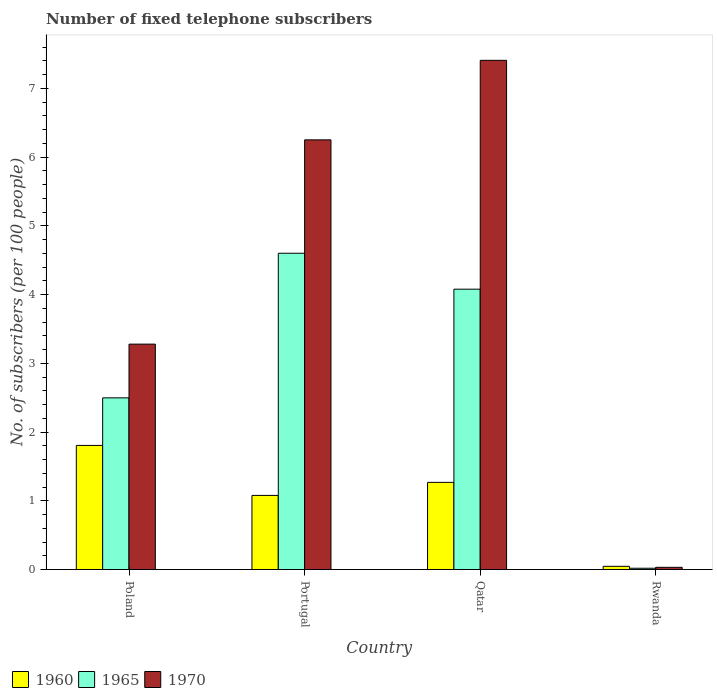How many groups of bars are there?
Give a very brief answer. 4. Are the number of bars per tick equal to the number of legend labels?
Make the answer very short. Yes. What is the label of the 2nd group of bars from the left?
Offer a terse response. Portugal. In how many cases, is the number of bars for a given country not equal to the number of legend labels?
Your answer should be compact. 0. What is the number of fixed telephone subscribers in 1960 in Poland?
Give a very brief answer. 1.81. Across all countries, what is the maximum number of fixed telephone subscribers in 1965?
Give a very brief answer. 4.6. Across all countries, what is the minimum number of fixed telephone subscribers in 1965?
Your response must be concise. 0.02. In which country was the number of fixed telephone subscribers in 1960 minimum?
Your answer should be very brief. Rwanda. What is the total number of fixed telephone subscribers in 1965 in the graph?
Your answer should be compact. 11.2. What is the difference between the number of fixed telephone subscribers in 1970 in Poland and that in Qatar?
Make the answer very short. -4.13. What is the difference between the number of fixed telephone subscribers in 1970 in Qatar and the number of fixed telephone subscribers in 1960 in Rwanda?
Offer a very short reply. 7.36. What is the average number of fixed telephone subscribers in 1960 per country?
Your answer should be compact. 1.05. What is the difference between the number of fixed telephone subscribers of/in 1970 and number of fixed telephone subscribers of/in 1965 in Poland?
Your response must be concise. 0.78. In how many countries, is the number of fixed telephone subscribers in 1960 greater than 5.4?
Offer a very short reply. 0. What is the ratio of the number of fixed telephone subscribers in 1960 in Portugal to that in Rwanda?
Make the answer very short. 23.15. What is the difference between the highest and the second highest number of fixed telephone subscribers in 1960?
Offer a terse response. 0.54. What is the difference between the highest and the lowest number of fixed telephone subscribers in 1960?
Make the answer very short. 1.76. In how many countries, is the number of fixed telephone subscribers in 1970 greater than the average number of fixed telephone subscribers in 1970 taken over all countries?
Provide a short and direct response. 2. What does the 3rd bar from the left in Qatar represents?
Provide a succinct answer. 1970. What does the 1st bar from the right in Qatar represents?
Your answer should be compact. 1970. Is it the case that in every country, the sum of the number of fixed telephone subscribers in 1960 and number of fixed telephone subscribers in 1965 is greater than the number of fixed telephone subscribers in 1970?
Your response must be concise. No. How many bars are there?
Your response must be concise. 12. What is the difference between two consecutive major ticks on the Y-axis?
Provide a short and direct response. 1. Are the values on the major ticks of Y-axis written in scientific E-notation?
Give a very brief answer. No. How many legend labels are there?
Your answer should be very brief. 3. How are the legend labels stacked?
Keep it short and to the point. Horizontal. What is the title of the graph?
Your answer should be compact. Number of fixed telephone subscribers. What is the label or title of the Y-axis?
Your response must be concise. No. of subscribers (per 100 people). What is the No. of subscribers (per 100 people) in 1960 in Poland?
Your response must be concise. 1.81. What is the No. of subscribers (per 100 people) of 1965 in Poland?
Your answer should be very brief. 2.5. What is the No. of subscribers (per 100 people) of 1970 in Poland?
Keep it short and to the point. 3.28. What is the No. of subscribers (per 100 people) in 1960 in Portugal?
Provide a short and direct response. 1.08. What is the No. of subscribers (per 100 people) in 1965 in Portugal?
Your answer should be compact. 4.6. What is the No. of subscribers (per 100 people) of 1970 in Portugal?
Your response must be concise. 6.25. What is the No. of subscribers (per 100 people) of 1960 in Qatar?
Give a very brief answer. 1.27. What is the No. of subscribers (per 100 people) in 1965 in Qatar?
Give a very brief answer. 4.08. What is the No. of subscribers (per 100 people) of 1970 in Qatar?
Your response must be concise. 7.41. What is the No. of subscribers (per 100 people) in 1960 in Rwanda?
Your answer should be compact. 0.05. What is the No. of subscribers (per 100 people) in 1965 in Rwanda?
Ensure brevity in your answer.  0.02. What is the No. of subscribers (per 100 people) of 1970 in Rwanda?
Offer a very short reply. 0.03. Across all countries, what is the maximum No. of subscribers (per 100 people) in 1960?
Make the answer very short. 1.81. Across all countries, what is the maximum No. of subscribers (per 100 people) in 1965?
Your answer should be compact. 4.6. Across all countries, what is the maximum No. of subscribers (per 100 people) in 1970?
Ensure brevity in your answer.  7.41. Across all countries, what is the minimum No. of subscribers (per 100 people) in 1960?
Provide a succinct answer. 0.05. Across all countries, what is the minimum No. of subscribers (per 100 people) in 1965?
Your answer should be compact. 0.02. Across all countries, what is the minimum No. of subscribers (per 100 people) in 1970?
Offer a very short reply. 0.03. What is the total No. of subscribers (per 100 people) of 1960 in the graph?
Your response must be concise. 4.2. What is the total No. of subscribers (per 100 people) of 1965 in the graph?
Ensure brevity in your answer.  11.2. What is the total No. of subscribers (per 100 people) of 1970 in the graph?
Provide a short and direct response. 16.97. What is the difference between the No. of subscribers (per 100 people) in 1960 in Poland and that in Portugal?
Your response must be concise. 0.73. What is the difference between the No. of subscribers (per 100 people) of 1965 in Poland and that in Portugal?
Offer a very short reply. -2.1. What is the difference between the No. of subscribers (per 100 people) of 1970 in Poland and that in Portugal?
Your answer should be compact. -2.97. What is the difference between the No. of subscribers (per 100 people) of 1960 in Poland and that in Qatar?
Your response must be concise. 0.54. What is the difference between the No. of subscribers (per 100 people) in 1965 in Poland and that in Qatar?
Make the answer very short. -1.58. What is the difference between the No. of subscribers (per 100 people) of 1970 in Poland and that in Qatar?
Offer a very short reply. -4.13. What is the difference between the No. of subscribers (per 100 people) of 1960 in Poland and that in Rwanda?
Offer a terse response. 1.76. What is the difference between the No. of subscribers (per 100 people) of 1965 in Poland and that in Rwanda?
Make the answer very short. 2.48. What is the difference between the No. of subscribers (per 100 people) in 1970 in Poland and that in Rwanda?
Make the answer very short. 3.25. What is the difference between the No. of subscribers (per 100 people) in 1960 in Portugal and that in Qatar?
Your response must be concise. -0.19. What is the difference between the No. of subscribers (per 100 people) in 1965 in Portugal and that in Qatar?
Make the answer very short. 0.52. What is the difference between the No. of subscribers (per 100 people) in 1970 in Portugal and that in Qatar?
Give a very brief answer. -1.16. What is the difference between the No. of subscribers (per 100 people) in 1960 in Portugal and that in Rwanda?
Offer a very short reply. 1.03. What is the difference between the No. of subscribers (per 100 people) in 1965 in Portugal and that in Rwanda?
Provide a succinct answer. 4.58. What is the difference between the No. of subscribers (per 100 people) in 1970 in Portugal and that in Rwanda?
Your answer should be very brief. 6.22. What is the difference between the No. of subscribers (per 100 people) of 1960 in Qatar and that in Rwanda?
Your answer should be very brief. 1.22. What is the difference between the No. of subscribers (per 100 people) of 1965 in Qatar and that in Rwanda?
Offer a terse response. 4.06. What is the difference between the No. of subscribers (per 100 people) in 1970 in Qatar and that in Rwanda?
Offer a very short reply. 7.38. What is the difference between the No. of subscribers (per 100 people) of 1960 in Poland and the No. of subscribers (per 100 people) of 1965 in Portugal?
Provide a short and direct response. -2.8. What is the difference between the No. of subscribers (per 100 people) of 1960 in Poland and the No. of subscribers (per 100 people) of 1970 in Portugal?
Provide a succinct answer. -4.45. What is the difference between the No. of subscribers (per 100 people) of 1965 in Poland and the No. of subscribers (per 100 people) of 1970 in Portugal?
Give a very brief answer. -3.75. What is the difference between the No. of subscribers (per 100 people) in 1960 in Poland and the No. of subscribers (per 100 people) in 1965 in Qatar?
Provide a short and direct response. -2.27. What is the difference between the No. of subscribers (per 100 people) in 1960 in Poland and the No. of subscribers (per 100 people) in 1970 in Qatar?
Your answer should be compact. -5.6. What is the difference between the No. of subscribers (per 100 people) in 1965 in Poland and the No. of subscribers (per 100 people) in 1970 in Qatar?
Give a very brief answer. -4.91. What is the difference between the No. of subscribers (per 100 people) in 1960 in Poland and the No. of subscribers (per 100 people) in 1965 in Rwanda?
Your response must be concise. 1.79. What is the difference between the No. of subscribers (per 100 people) in 1960 in Poland and the No. of subscribers (per 100 people) in 1970 in Rwanda?
Keep it short and to the point. 1.77. What is the difference between the No. of subscribers (per 100 people) in 1965 in Poland and the No. of subscribers (per 100 people) in 1970 in Rwanda?
Make the answer very short. 2.47. What is the difference between the No. of subscribers (per 100 people) in 1960 in Portugal and the No. of subscribers (per 100 people) in 1965 in Qatar?
Your answer should be very brief. -3. What is the difference between the No. of subscribers (per 100 people) in 1960 in Portugal and the No. of subscribers (per 100 people) in 1970 in Qatar?
Provide a short and direct response. -6.33. What is the difference between the No. of subscribers (per 100 people) of 1965 in Portugal and the No. of subscribers (per 100 people) of 1970 in Qatar?
Your answer should be compact. -2.81. What is the difference between the No. of subscribers (per 100 people) in 1960 in Portugal and the No. of subscribers (per 100 people) in 1965 in Rwanda?
Offer a very short reply. 1.06. What is the difference between the No. of subscribers (per 100 people) in 1960 in Portugal and the No. of subscribers (per 100 people) in 1970 in Rwanda?
Ensure brevity in your answer.  1.05. What is the difference between the No. of subscribers (per 100 people) in 1965 in Portugal and the No. of subscribers (per 100 people) in 1970 in Rwanda?
Keep it short and to the point. 4.57. What is the difference between the No. of subscribers (per 100 people) in 1960 in Qatar and the No. of subscribers (per 100 people) in 1965 in Rwanda?
Keep it short and to the point. 1.25. What is the difference between the No. of subscribers (per 100 people) of 1960 in Qatar and the No. of subscribers (per 100 people) of 1970 in Rwanda?
Keep it short and to the point. 1.24. What is the difference between the No. of subscribers (per 100 people) in 1965 in Qatar and the No. of subscribers (per 100 people) in 1970 in Rwanda?
Your response must be concise. 4.05. What is the average No. of subscribers (per 100 people) of 1960 per country?
Offer a terse response. 1.05. What is the average No. of subscribers (per 100 people) of 1965 per country?
Offer a very short reply. 2.8. What is the average No. of subscribers (per 100 people) of 1970 per country?
Give a very brief answer. 4.24. What is the difference between the No. of subscribers (per 100 people) in 1960 and No. of subscribers (per 100 people) in 1965 in Poland?
Provide a succinct answer. -0.69. What is the difference between the No. of subscribers (per 100 people) of 1960 and No. of subscribers (per 100 people) of 1970 in Poland?
Provide a short and direct response. -1.47. What is the difference between the No. of subscribers (per 100 people) of 1965 and No. of subscribers (per 100 people) of 1970 in Poland?
Your answer should be compact. -0.78. What is the difference between the No. of subscribers (per 100 people) of 1960 and No. of subscribers (per 100 people) of 1965 in Portugal?
Make the answer very short. -3.52. What is the difference between the No. of subscribers (per 100 people) in 1960 and No. of subscribers (per 100 people) in 1970 in Portugal?
Offer a very short reply. -5.17. What is the difference between the No. of subscribers (per 100 people) of 1965 and No. of subscribers (per 100 people) of 1970 in Portugal?
Your answer should be very brief. -1.65. What is the difference between the No. of subscribers (per 100 people) of 1960 and No. of subscribers (per 100 people) of 1965 in Qatar?
Your response must be concise. -2.81. What is the difference between the No. of subscribers (per 100 people) of 1960 and No. of subscribers (per 100 people) of 1970 in Qatar?
Make the answer very short. -6.14. What is the difference between the No. of subscribers (per 100 people) of 1965 and No. of subscribers (per 100 people) of 1970 in Qatar?
Keep it short and to the point. -3.33. What is the difference between the No. of subscribers (per 100 people) in 1960 and No. of subscribers (per 100 people) in 1965 in Rwanda?
Make the answer very short. 0.03. What is the difference between the No. of subscribers (per 100 people) of 1960 and No. of subscribers (per 100 people) of 1970 in Rwanda?
Make the answer very short. 0.01. What is the difference between the No. of subscribers (per 100 people) in 1965 and No. of subscribers (per 100 people) in 1970 in Rwanda?
Provide a short and direct response. -0.01. What is the ratio of the No. of subscribers (per 100 people) in 1960 in Poland to that in Portugal?
Provide a short and direct response. 1.67. What is the ratio of the No. of subscribers (per 100 people) in 1965 in Poland to that in Portugal?
Your answer should be compact. 0.54. What is the ratio of the No. of subscribers (per 100 people) of 1970 in Poland to that in Portugal?
Your answer should be very brief. 0.52. What is the ratio of the No. of subscribers (per 100 people) in 1960 in Poland to that in Qatar?
Offer a terse response. 1.42. What is the ratio of the No. of subscribers (per 100 people) in 1965 in Poland to that in Qatar?
Provide a short and direct response. 0.61. What is the ratio of the No. of subscribers (per 100 people) in 1970 in Poland to that in Qatar?
Your answer should be compact. 0.44. What is the ratio of the No. of subscribers (per 100 people) in 1960 in Poland to that in Rwanda?
Give a very brief answer. 38.77. What is the ratio of the No. of subscribers (per 100 people) in 1965 in Poland to that in Rwanda?
Ensure brevity in your answer.  134.57. What is the ratio of the No. of subscribers (per 100 people) in 1970 in Poland to that in Rwanda?
Give a very brief answer. 102.59. What is the ratio of the No. of subscribers (per 100 people) of 1960 in Portugal to that in Qatar?
Ensure brevity in your answer.  0.85. What is the ratio of the No. of subscribers (per 100 people) in 1965 in Portugal to that in Qatar?
Provide a short and direct response. 1.13. What is the ratio of the No. of subscribers (per 100 people) in 1970 in Portugal to that in Qatar?
Your answer should be very brief. 0.84. What is the ratio of the No. of subscribers (per 100 people) in 1960 in Portugal to that in Rwanda?
Give a very brief answer. 23.15. What is the ratio of the No. of subscribers (per 100 people) in 1965 in Portugal to that in Rwanda?
Provide a short and direct response. 247.93. What is the ratio of the No. of subscribers (per 100 people) of 1970 in Portugal to that in Rwanda?
Offer a very short reply. 195.59. What is the ratio of the No. of subscribers (per 100 people) in 1960 in Qatar to that in Rwanda?
Your answer should be compact. 27.23. What is the ratio of the No. of subscribers (per 100 people) in 1965 in Qatar to that in Rwanda?
Offer a terse response. 219.77. What is the ratio of the No. of subscribers (per 100 people) in 1970 in Qatar to that in Rwanda?
Ensure brevity in your answer.  231.78. What is the difference between the highest and the second highest No. of subscribers (per 100 people) of 1960?
Give a very brief answer. 0.54. What is the difference between the highest and the second highest No. of subscribers (per 100 people) in 1965?
Your answer should be compact. 0.52. What is the difference between the highest and the second highest No. of subscribers (per 100 people) of 1970?
Offer a terse response. 1.16. What is the difference between the highest and the lowest No. of subscribers (per 100 people) of 1960?
Ensure brevity in your answer.  1.76. What is the difference between the highest and the lowest No. of subscribers (per 100 people) of 1965?
Ensure brevity in your answer.  4.58. What is the difference between the highest and the lowest No. of subscribers (per 100 people) of 1970?
Provide a short and direct response. 7.38. 